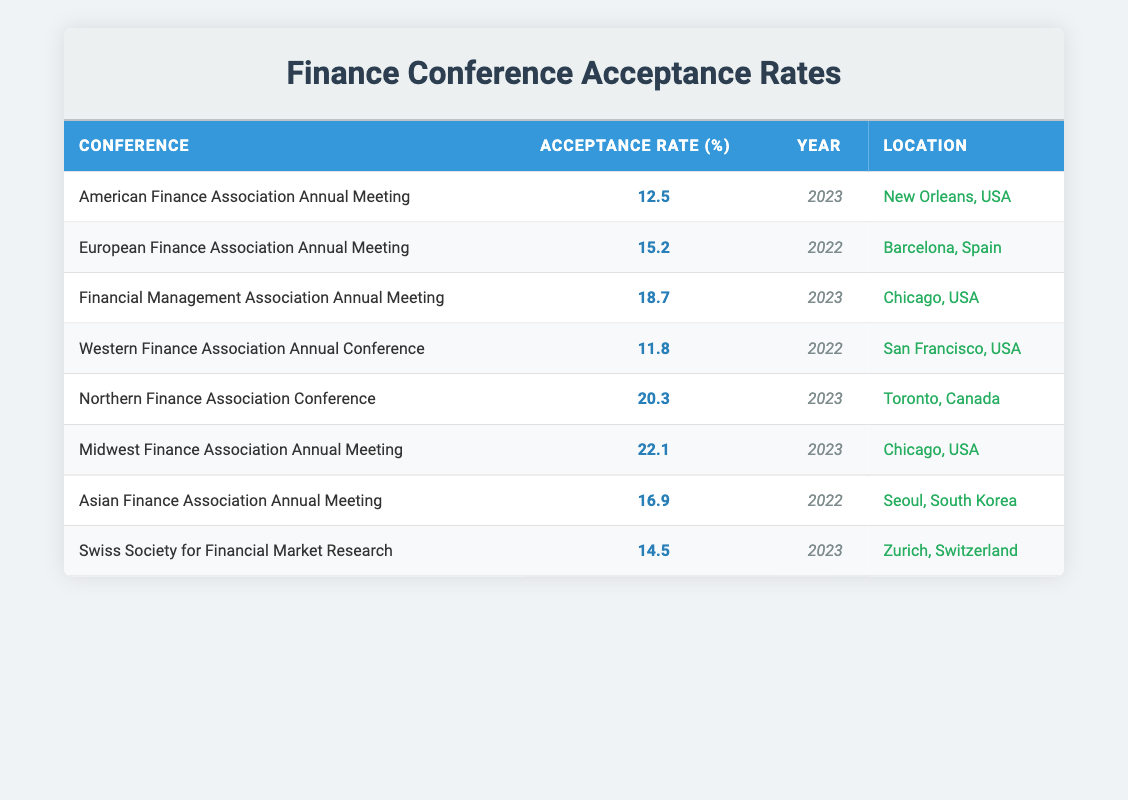What was the acceptance rate for the American Finance Association Annual Meeting in 2023? The acceptance rate for that conference is explicitly listed in the table under the "Acceptance Rate (%)" column for the entry corresponding to "American Finance Association Annual Meeting" and the year "2023". The value is 12.5.
Answer: 12.5 Which conference had the highest acceptance rate in 2023? To find this, we look for the highest value in the "Acceptance Rate (%)" column specifically for the year 2023. The conferences listed for 2023 are: American Finance Association Annual Meeting (12.5), Financial Management Association Annual Meeting (18.7), Northern Finance Association Conference (20.3), Midwest Finance Association Annual Meeting (22.1), and Swiss Society for Financial Market Research (14.5). The highest acceptance rate is 22.1 for the Midwest Finance Association Annual Meeting.
Answer: 22.1 Is the acceptance rate for the Northern Finance Association Conference greater than 20%? Checking the acceptance rate provided in the table for the Northern Finance Association Conference reveals that it is 20.3%, which is greater than 20%. Therefore, the answer is yes.
Answer: Yes What is the average acceptance rate for conferences held in 2023? First, we identify all the conferences held in 2023 from the table, which are the American Finance Association Annual Meeting (12.5), Financial Management Association Annual Meeting (18.7), Northern Finance Association Conference (20.3), Midwest Finance Association Annual Meeting (22.1), and Swiss Society for Financial Market Research (14.5). Summing these values gives us 12.5 + 18.7 + 20.3 + 22.1 + 14.5 = 88.1. Since there are 5 data points, we divide that sum by 5: 88.1 / 5 = 17.62.
Answer: 17.62 Which conference took place in Toronto? The location of Toronto is listed in the "Location" column, and the corresponding conference is the Northern Finance Association Conference.
Answer: Northern Finance Association Conference What was the acceptance rate for the Asian Finance Association Annual Meeting? Looking at the table for the Asian Finance Association Annual Meeting, the acceptance rate is found under "Acceptance Rate (%)", which shows a value of 16.9.
Answer: 16.9 Was the Western Finance Association Annual Conference held in 2023? We can see in the table that the Western Finance Association Annual Conference is listed with the year 2022. Therefore, it was not held in 2023.
Answer: No What is the difference between the highest and lowest acceptance rates in the table? The highest acceptance rate is for the Midwest Finance Association Annual Meeting at 22.1, and the lowest is for the Western Finance Association Annual Conference at 11.8. To find the difference, we calculate 22.1 - 11.8 = 10.3.
Answer: 10.3 